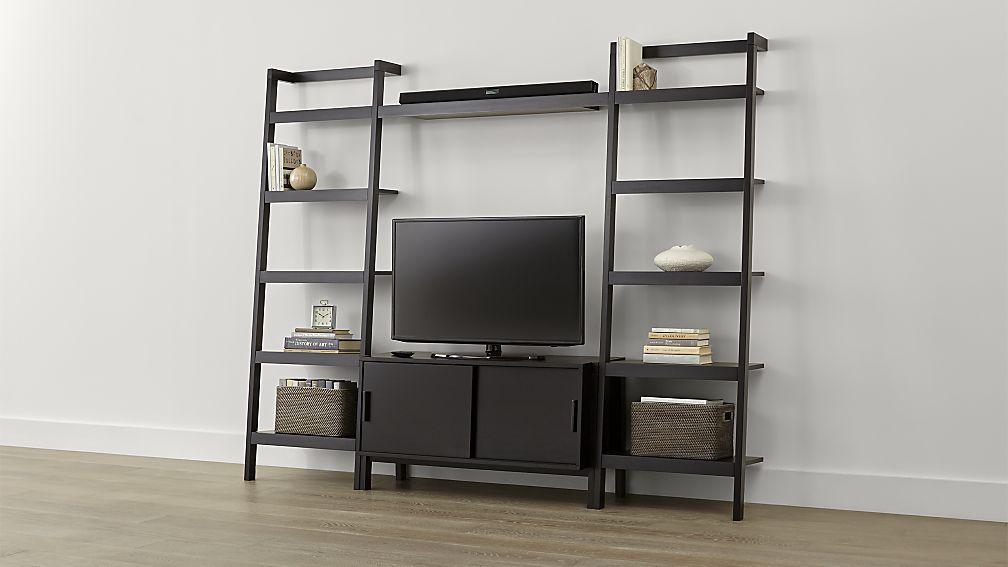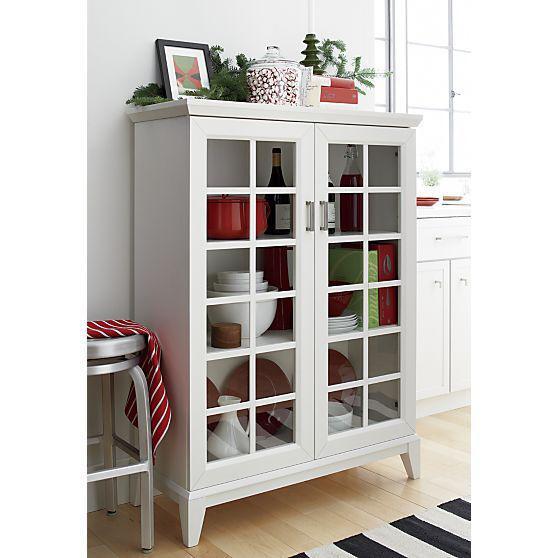The first image is the image on the left, the second image is the image on the right. Considering the images on both sides, is "An image shows a white storage unit with at least one item on its flat top." valid? Answer yes or no. Yes. The first image is the image on the left, the second image is the image on the right. Evaluate the accuracy of this statement regarding the images: "In one image, a shelf unit has six levels and an open back, while the shelf unit in the second image has fewer shelves and a solid enclosed back.". Is it true? Answer yes or no. No. 